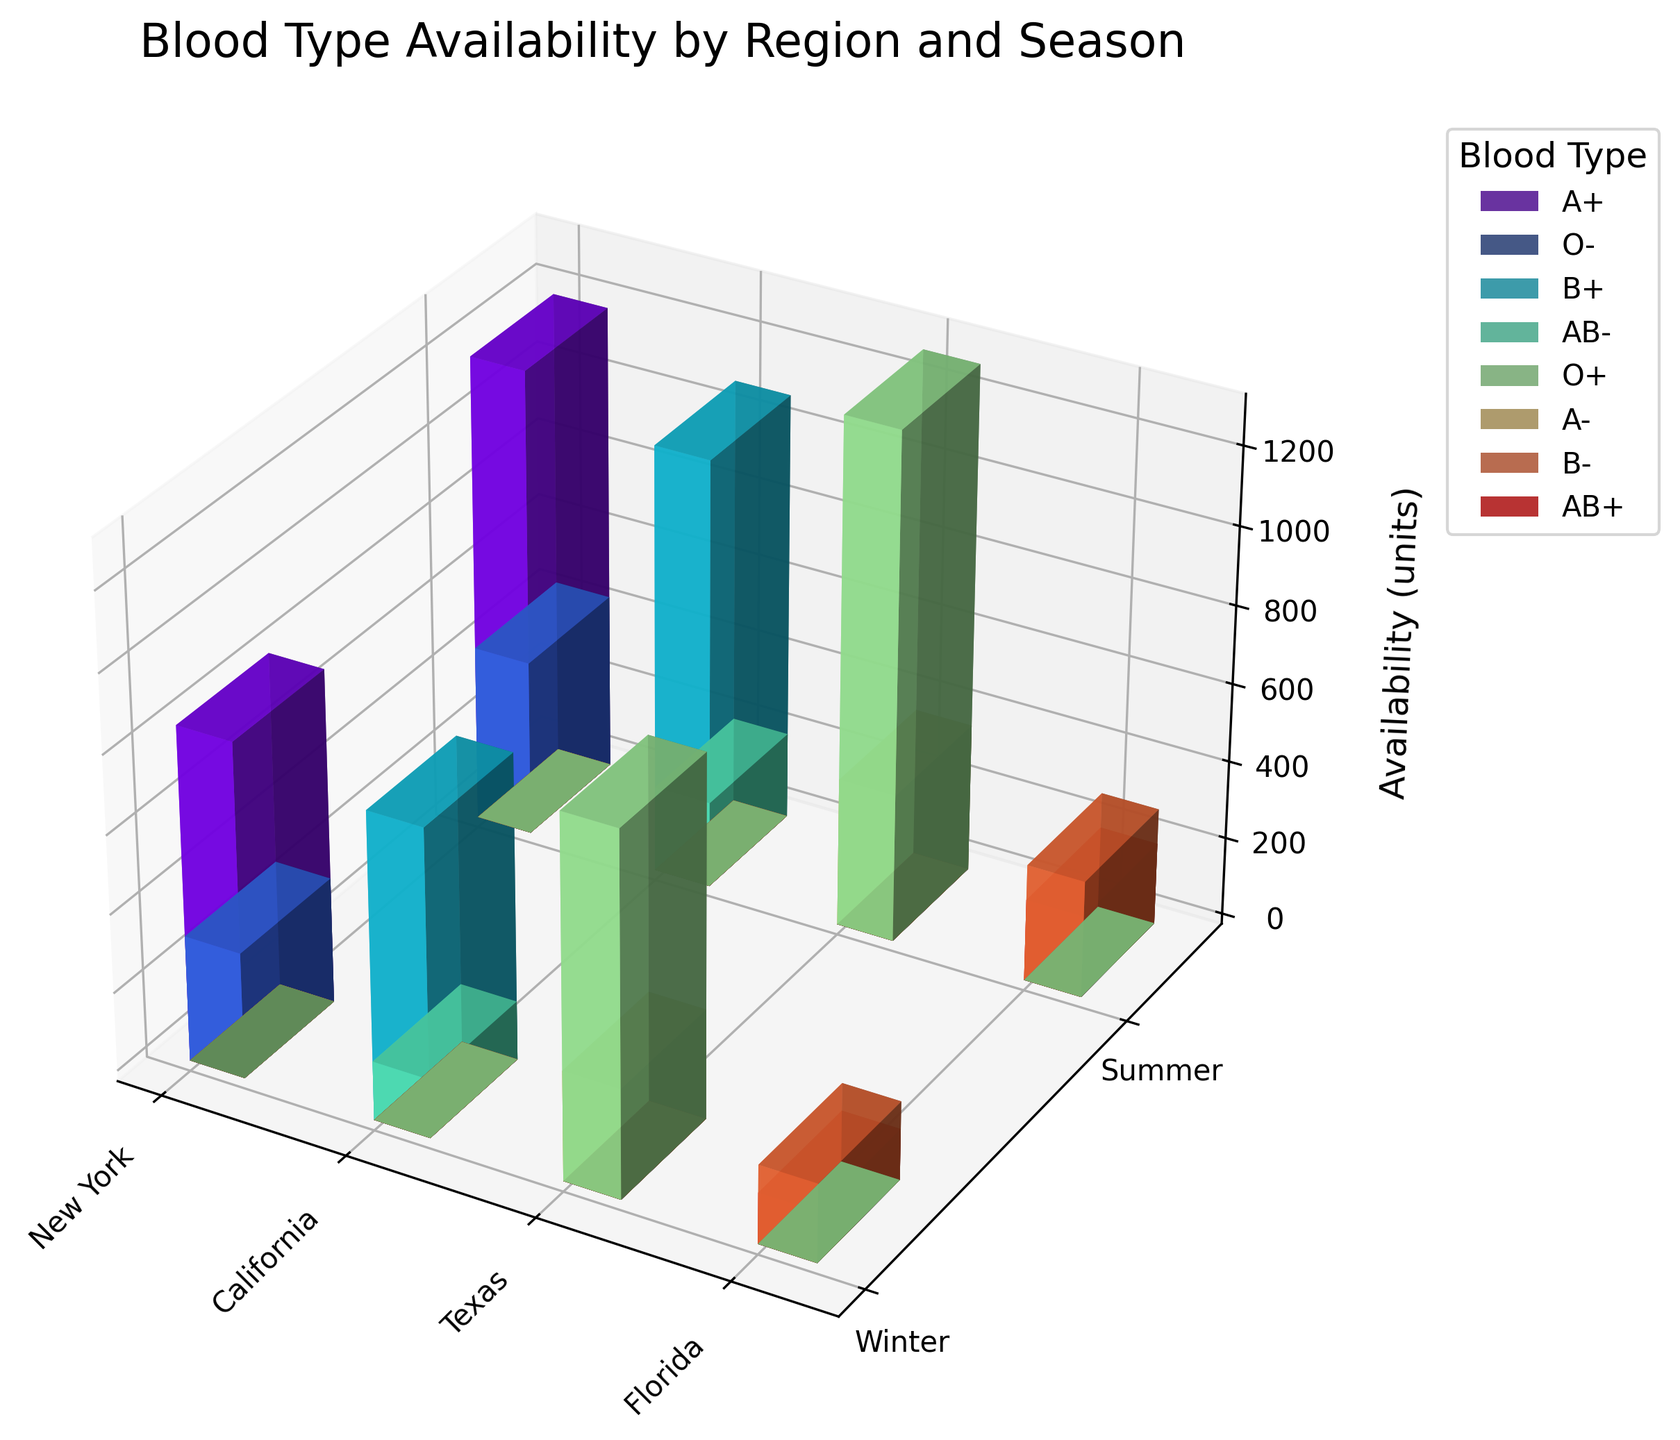What's the title of the figure? The title is located at the top of the figure, summarizing its content. The title text is usually larger and bolder than other text elements in the plot.
Answer: Blood Type Availability by Region and Season How many regions are represented in the figure? Identify the number of unique categories along the x-axis, which represent different regions. Each bar cluster for a set of seasons corresponds to a distinct region.
Answer: 4 Which blood type has the highest availability in any region and season? Locate the tallest bar in the plot, check its color, and refer to the legend to identify the blood type associated with that color.
Answer: A+ in New York, Summer What is the availability of O- blood type in New York during the winter season? Find the cluster of bars corresponding to New York in the winter, then identify the bar with the color representing O- blood type from the legend and read its height.
Answer: 320 units Which region has the least availability of AB- blood type during the summer season? Identify the bars corresponding to the AB- blood type using the legend and focus on the summer season. Then, compare the heights of these AB- bars across different regions and find the shortest one.
Answer: California Compare the donation rates for O+ and A- blood types in Texas during the summer season and explain which one is higher. Locate the relevant bars for Texas in the summer for both O+ and A- blood types by checking their colors in the legend. Compare the heights to determine which one is taller.
Answer: O+ is higher What is the difference in availability between B+ blood type in California during winter and summer? Identify the B+ bars in California for both winter and summer by referencing the legend. Then, subtract the lower value from the higher value.
Answer: 320 units (1100 - 780) Which season generally has higher blood type availability across the shown regions? Look at the average height of the bars in each season across all regions. Determine if the average height of the bars in one season is generally higher than in the other.
Answer: Summer Find the total availability of AB- blood type in all regions during both winter and summer seasons. Locate all bars for AB- blood type by checking the legend. Sum the heights (units) of these bars across both winter and summer for all regions.
Answer: 370 units (150 in Winter + 220 in Summer) What is the trend in blood type availability for A+ in New York across the seasons? Examine the heights of the A+ bars in New York by using the legend. Compare the winter and summer values to identify if there is an increase or decrease.
Answer: Increases from winter to summer (850 to 1200 units) 